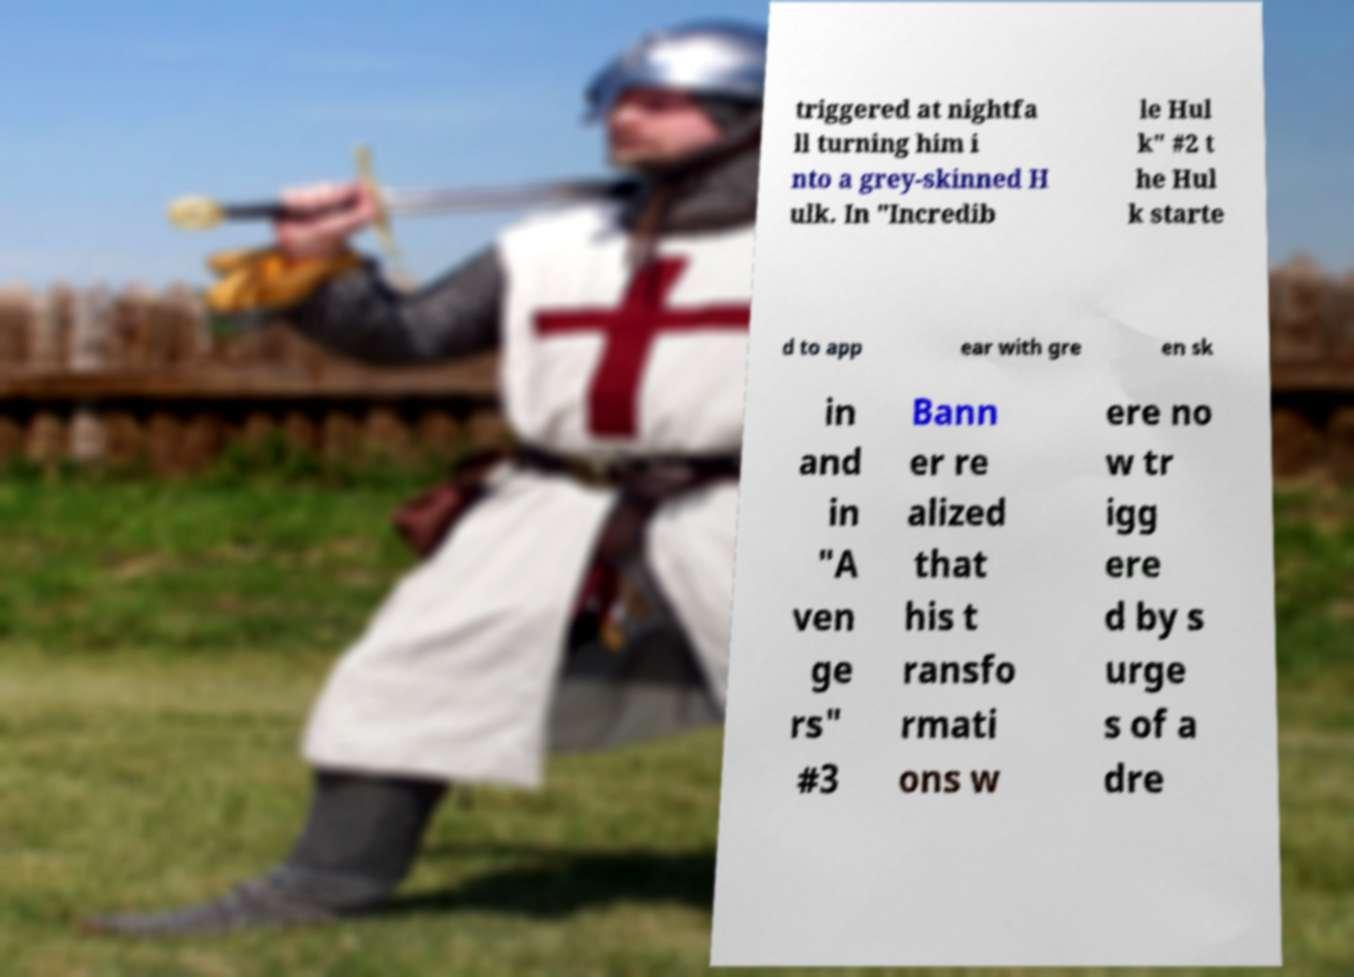There's text embedded in this image that I need extracted. Can you transcribe it verbatim? triggered at nightfa ll turning him i nto a grey-skinned H ulk. In "Incredib le Hul k" #2 t he Hul k starte d to app ear with gre en sk in and in "A ven ge rs" #3 Bann er re alized that his t ransfo rmati ons w ere no w tr igg ere d by s urge s of a dre 